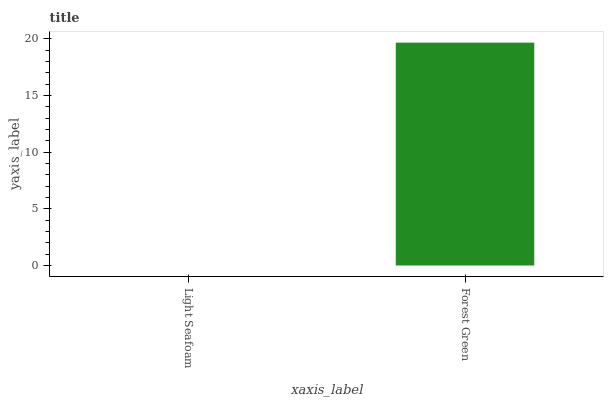Is Forest Green the minimum?
Answer yes or no. No. Is Forest Green greater than Light Seafoam?
Answer yes or no. Yes. Is Light Seafoam less than Forest Green?
Answer yes or no. Yes. Is Light Seafoam greater than Forest Green?
Answer yes or no. No. Is Forest Green less than Light Seafoam?
Answer yes or no. No. Is Forest Green the high median?
Answer yes or no. Yes. Is Light Seafoam the low median?
Answer yes or no. Yes. Is Light Seafoam the high median?
Answer yes or no. No. Is Forest Green the low median?
Answer yes or no. No. 